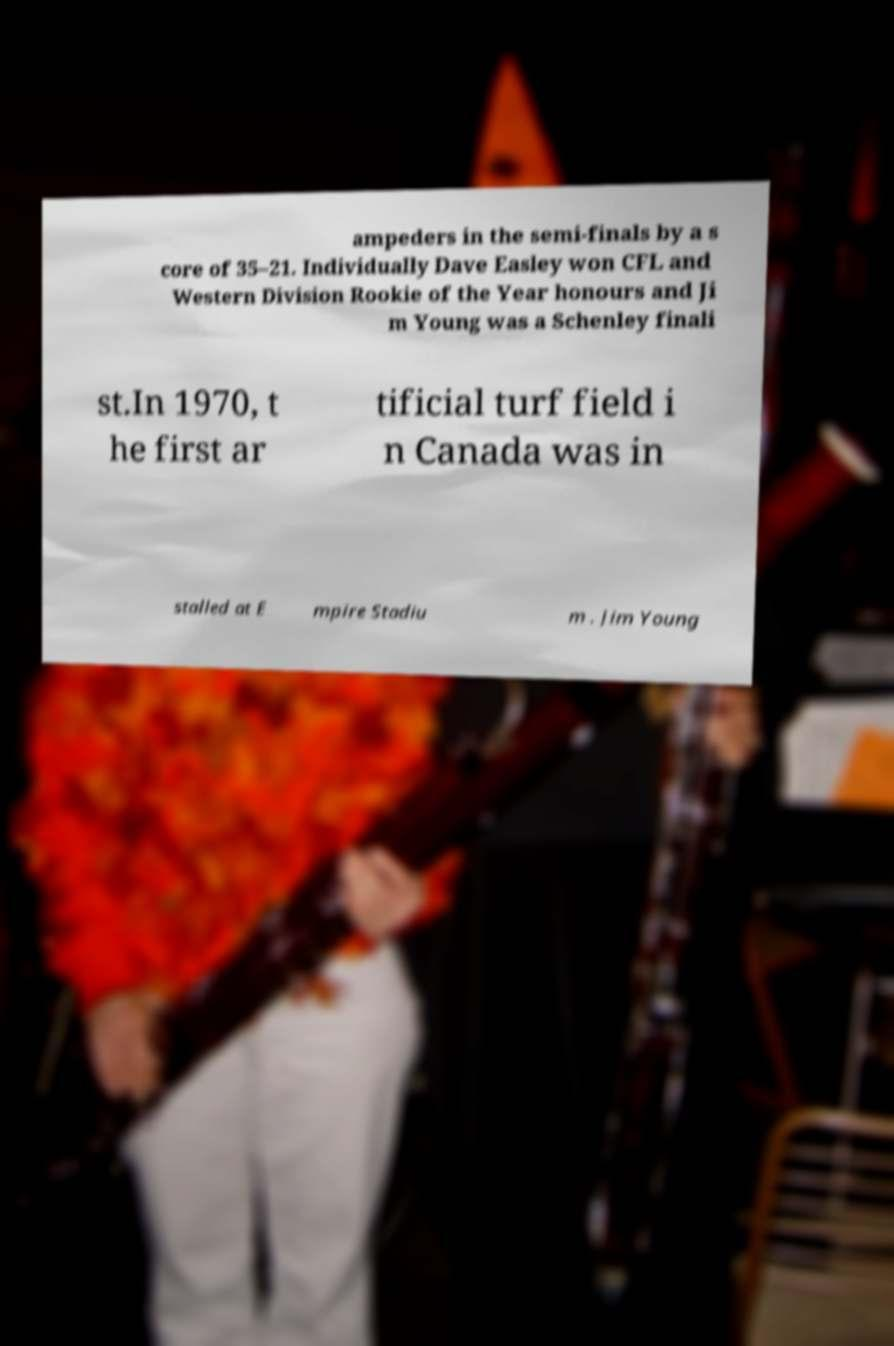Could you assist in decoding the text presented in this image and type it out clearly? ampeders in the semi-finals by a s core of 35–21. Individually Dave Easley won CFL and Western Division Rookie of the Year honours and Ji m Young was a Schenley finali st.In 1970, t he first ar tificial turf field i n Canada was in stalled at E mpire Stadiu m . Jim Young 